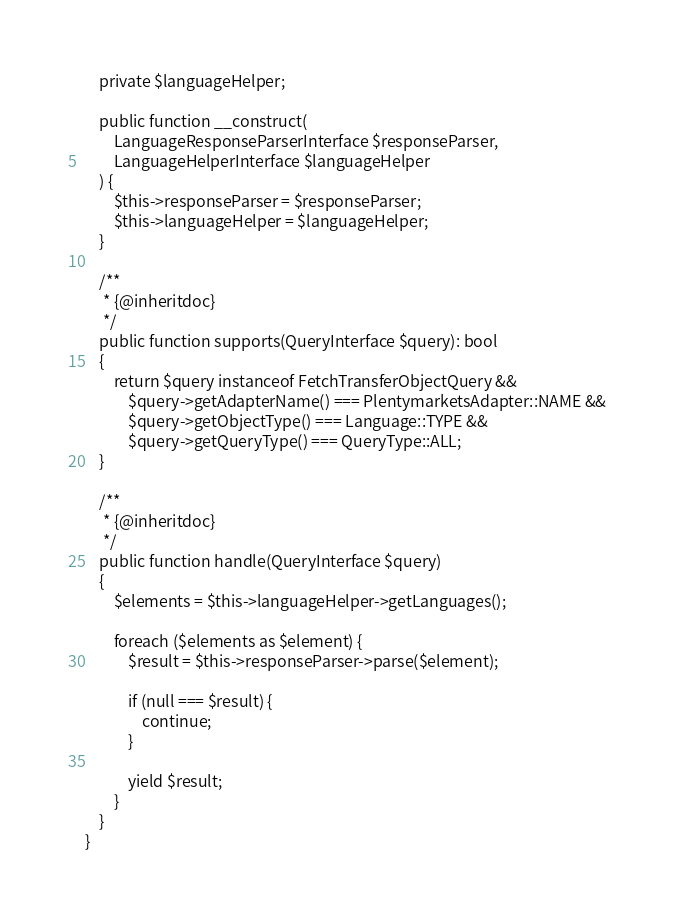Convert code to text. <code><loc_0><loc_0><loc_500><loc_500><_PHP_>    private $languageHelper;

    public function __construct(
        LanguageResponseParserInterface $responseParser,
        LanguageHelperInterface $languageHelper
    ) {
        $this->responseParser = $responseParser;
        $this->languageHelper = $languageHelper;
    }

    /**
     * {@inheritdoc}
     */
    public function supports(QueryInterface $query): bool
    {
        return $query instanceof FetchTransferObjectQuery &&
            $query->getAdapterName() === PlentymarketsAdapter::NAME &&
            $query->getObjectType() === Language::TYPE &&
            $query->getQueryType() === QueryType::ALL;
    }

    /**
     * {@inheritdoc}
     */
    public function handle(QueryInterface $query)
    {
        $elements = $this->languageHelper->getLanguages();

        foreach ($elements as $element) {
            $result = $this->responseParser->parse($element);

            if (null === $result) {
                continue;
            }

            yield $result;
        }
    }
}
</code> 